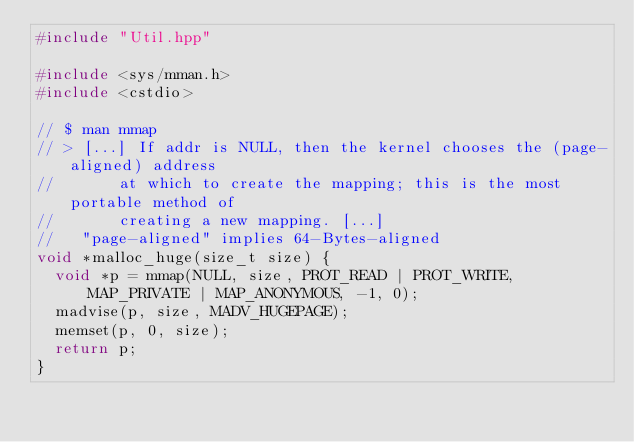<code> <loc_0><loc_0><loc_500><loc_500><_C++_>#include "Util.hpp"

#include <sys/mman.h>
#include <cstdio>

// $ man mmap
// > [...] If addr is NULL, then the kernel chooses the (page-aligned) address
//       at which to create the mapping; this is the most portable method of
//       creating a new mapping. [...]
//   "page-aligned" implies 64-Bytes-aligned
void *malloc_huge(size_t size) {
  void *p = mmap(NULL, size, PROT_READ | PROT_WRITE, MAP_PRIVATE | MAP_ANONYMOUS, -1, 0);
  madvise(p, size, MADV_HUGEPAGE);
  memset(p, 0, size);
  return p;
}
</code> 